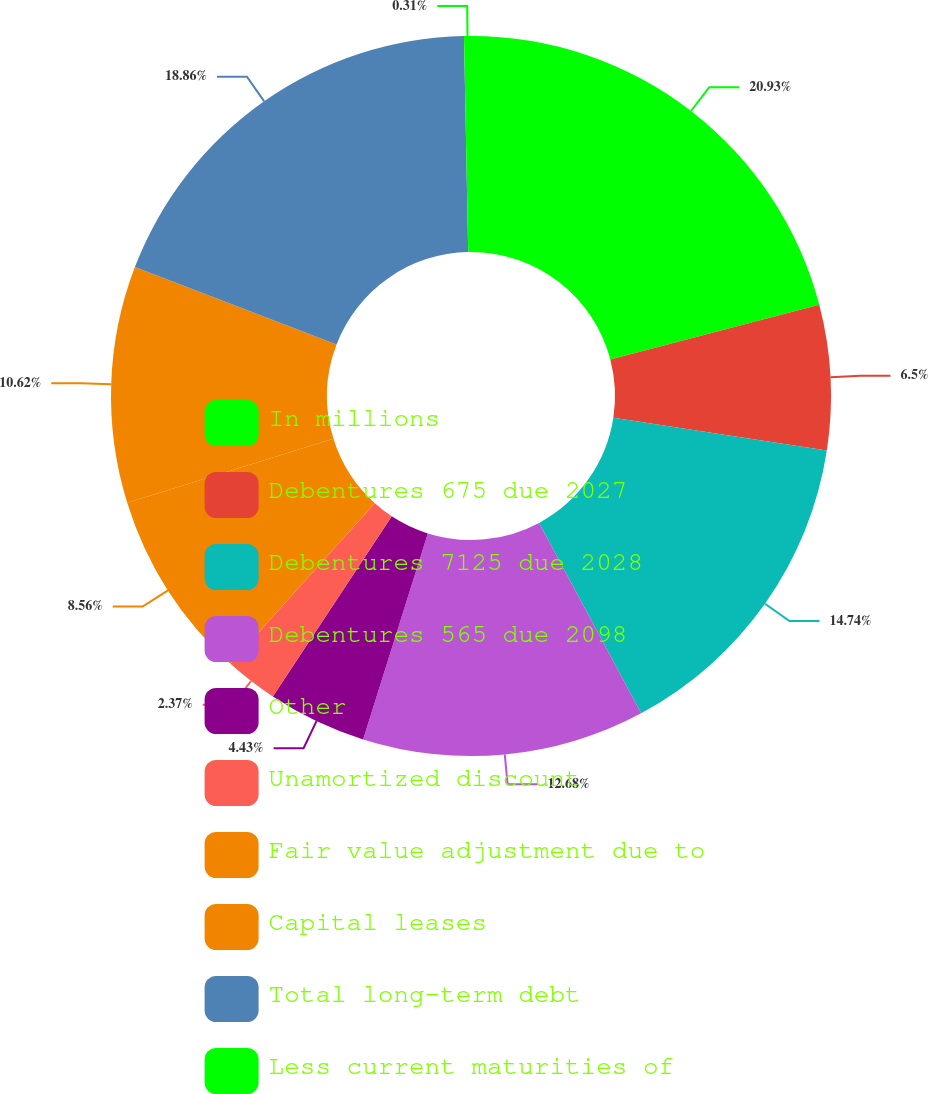Convert chart. <chart><loc_0><loc_0><loc_500><loc_500><pie_chart><fcel>In millions<fcel>Debentures 675 due 2027<fcel>Debentures 7125 due 2028<fcel>Debentures 565 due 2098<fcel>Other<fcel>Unamortized discount<fcel>Fair value adjustment due to<fcel>Capital leases<fcel>Total long-term debt<fcel>Less current maturities of<nl><fcel>20.92%<fcel>6.5%<fcel>14.74%<fcel>12.68%<fcel>4.43%<fcel>2.37%<fcel>8.56%<fcel>10.62%<fcel>18.86%<fcel>0.31%<nl></chart> 